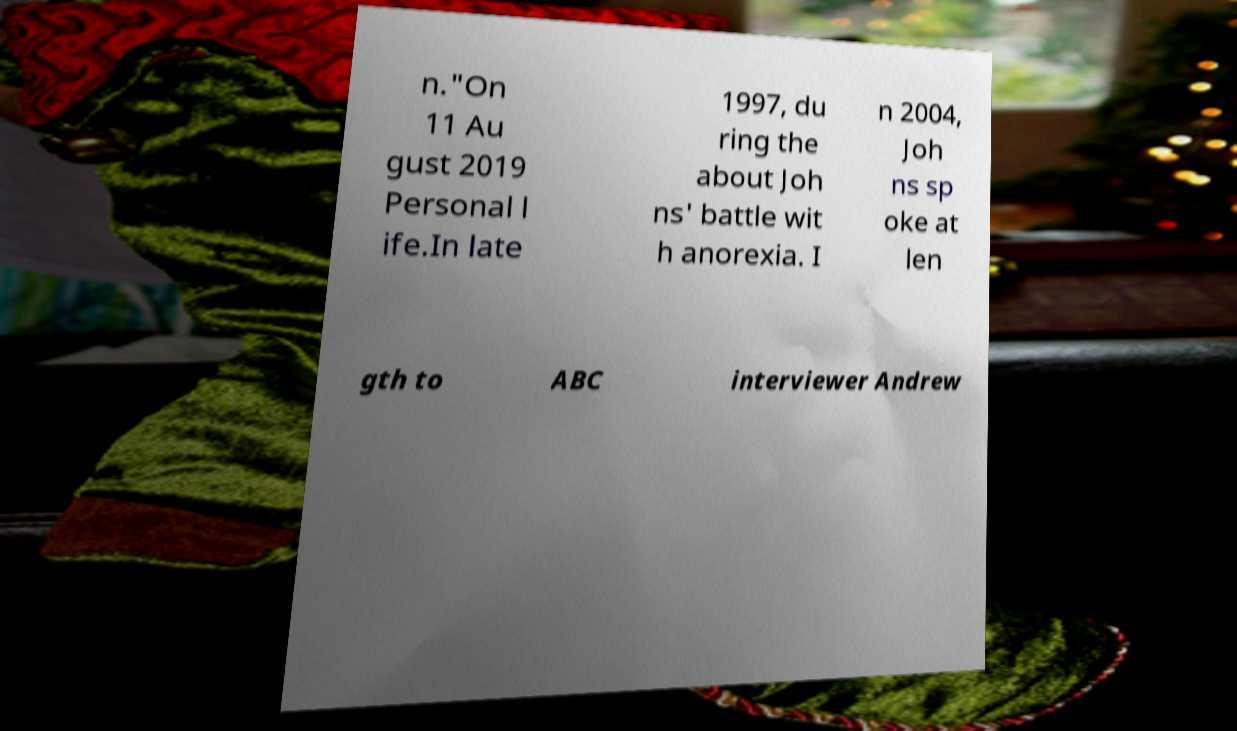For documentation purposes, I need the text within this image transcribed. Could you provide that? n."On 11 Au gust 2019 Personal l ife.In late 1997, du ring the about Joh ns' battle wit h anorexia. I n 2004, Joh ns sp oke at len gth to ABC interviewer Andrew 